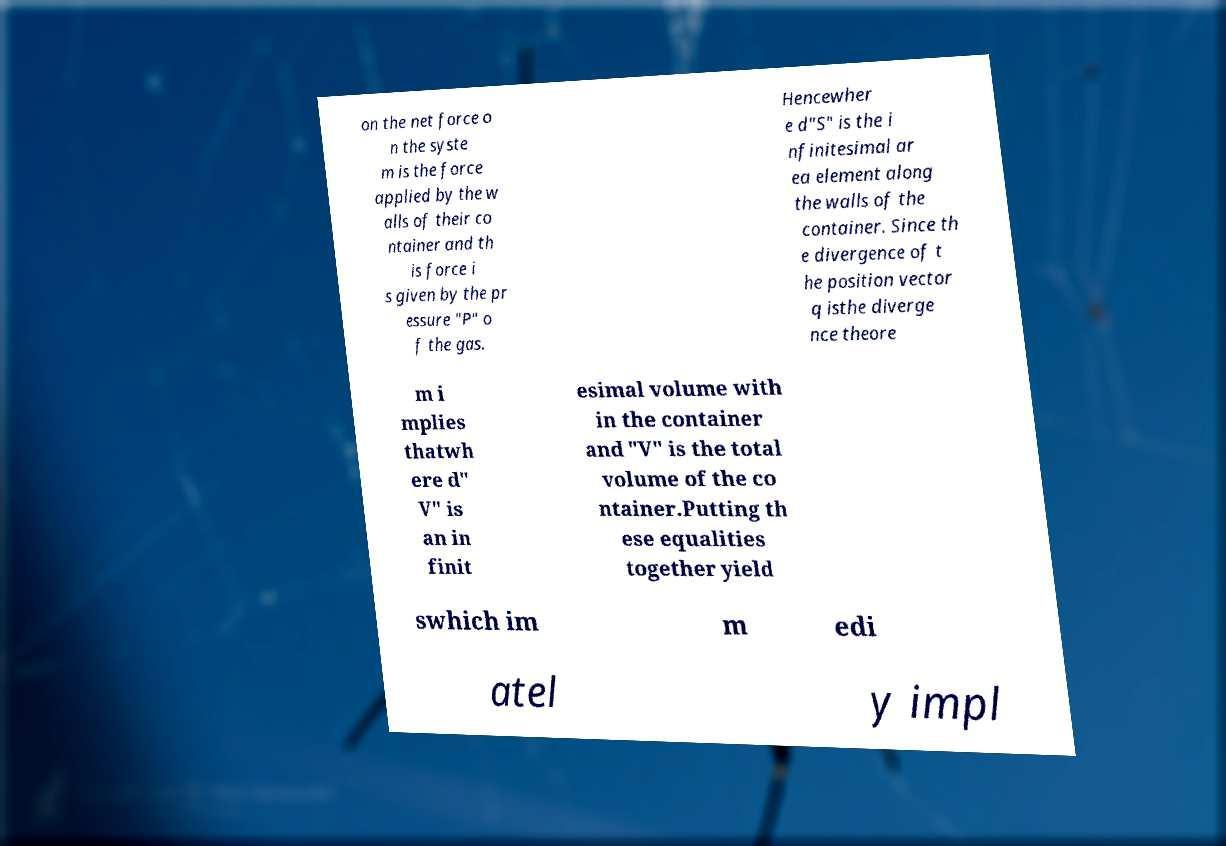Could you extract and type out the text from this image? on the net force o n the syste m is the force applied by the w alls of their co ntainer and th is force i s given by the pr essure "P" o f the gas. Hencewher e d"S" is the i nfinitesimal ar ea element along the walls of the container. Since th e divergence of t he position vector q isthe diverge nce theore m i mplies thatwh ere d" V" is an in finit esimal volume with in the container and "V" is the total volume of the co ntainer.Putting th ese equalities together yield swhich im m edi atel y impl 